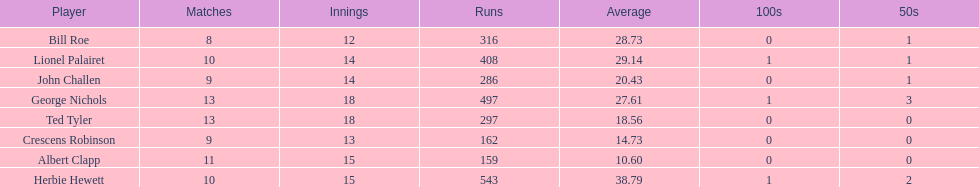What is the least about of runs anyone has? 159. 